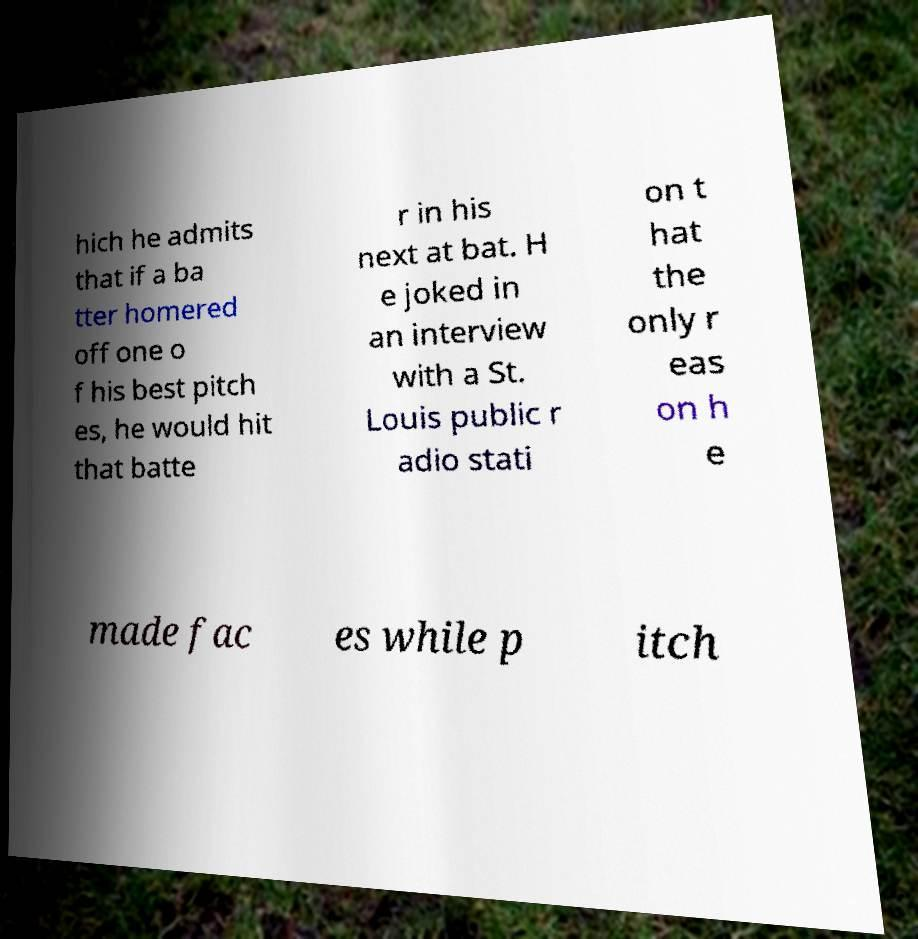What messages or text are displayed in this image? I need them in a readable, typed format. hich he admits that if a ba tter homered off one o f his best pitch es, he would hit that batte r in his next at bat. H e joked in an interview with a St. Louis public r adio stati on t hat the only r eas on h e made fac es while p itch 